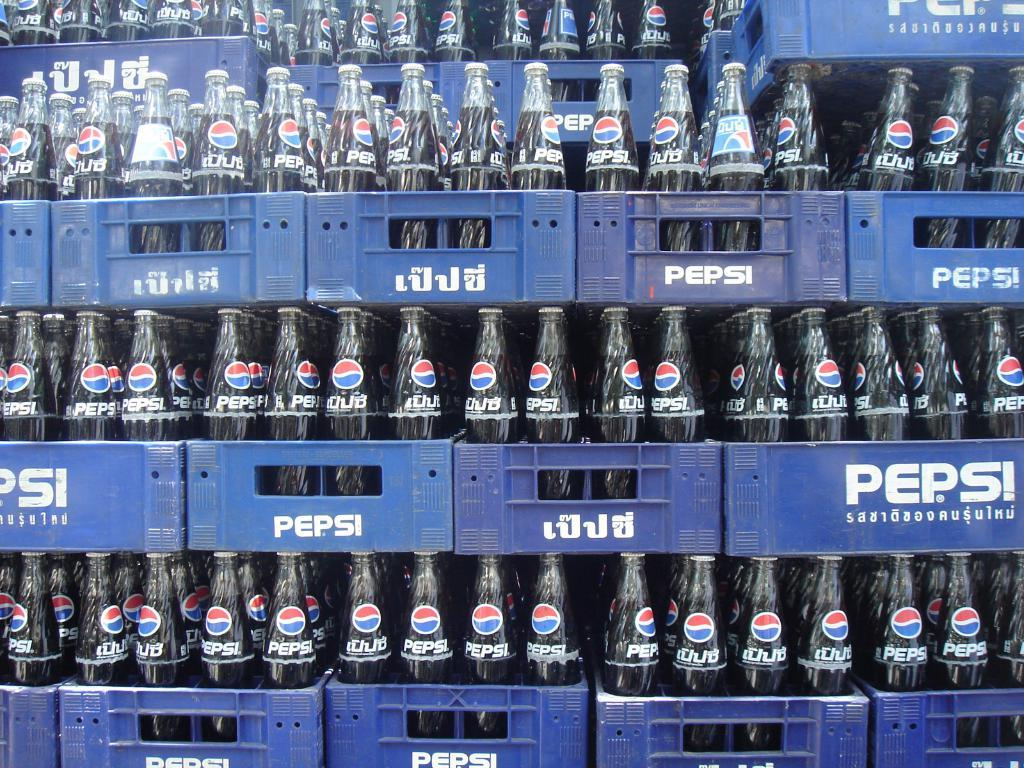What type of bottles are visible in the image? There are Pepsi bottles in the image. How are the bottles sealed? The bottles have closed metal caps. What color are the baskets in which the bottles are placed? The bottles are placed in blue color baskets. What type of calculator is being used by the person standing next to the building in the image? There is no person, calculator, or building present in the image. 